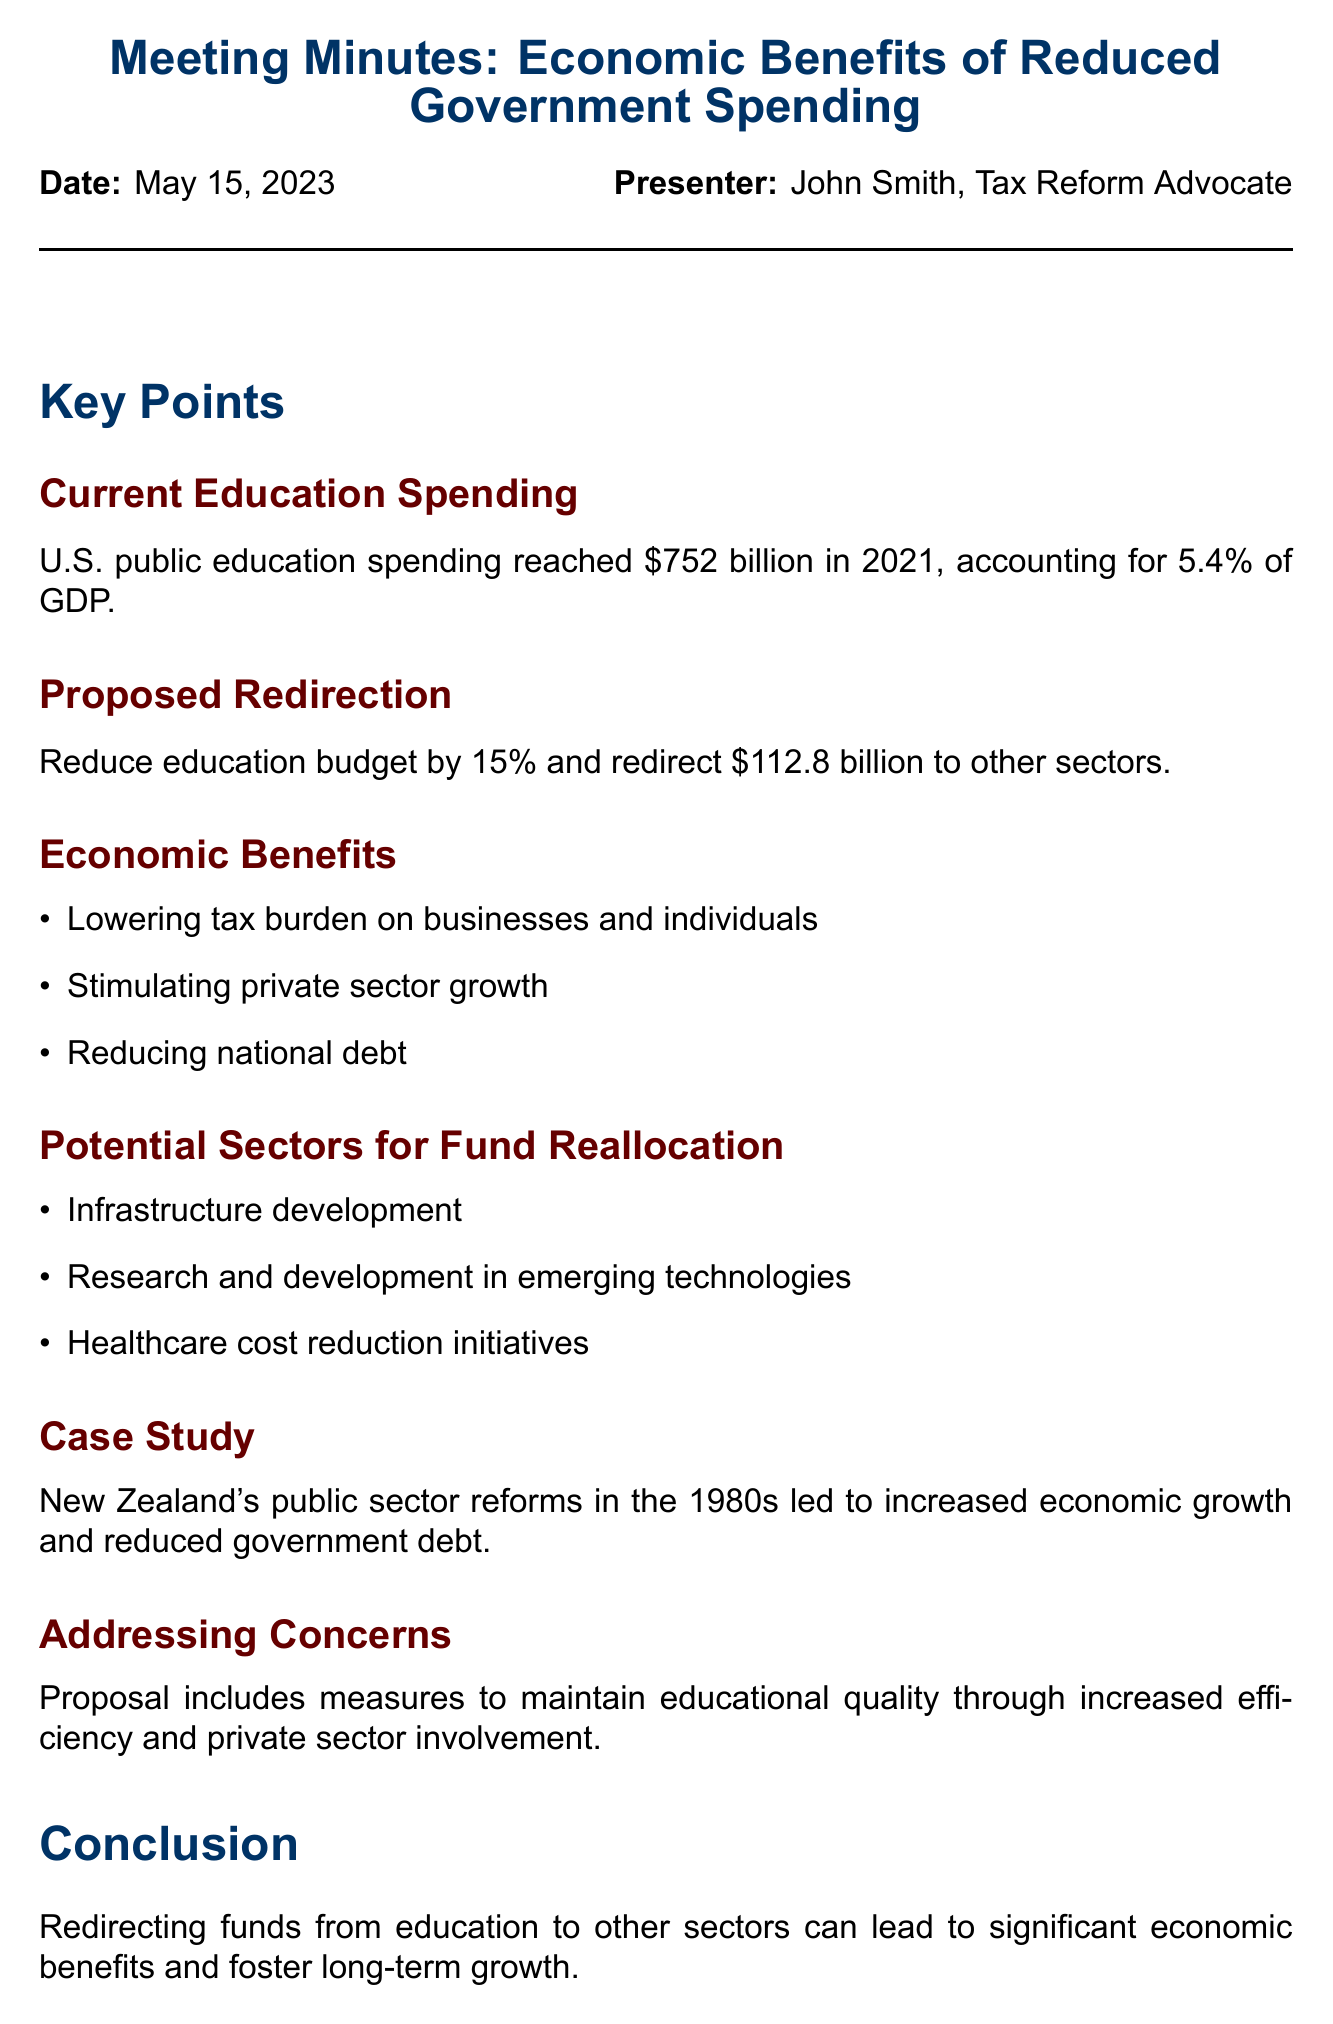What is the date of the meeting? The date of the meeting is stated at the beginning of the document.
Answer: May 15, 2023 Who is the presenter of the meeting? The presenter's name is mentioned right after the date.
Answer: John Smith, Tax Reform Advocate What percentage of GDP did U.S. public education spending account for in 2021? The percentage is specified in the section about current education spending.
Answer: 5.4% What is the proposed percentage reduction in the education budget? The proposed reduction is outlined in the proposed redirection section.
Answer: 15% How much money is proposed to be redirected to other sectors? The amount to be redirected is stated in the details of the proposed redirection.
Answer: $112.8 billion What was a significant effect of New Zealand's public sector reforms in the 1980s? The effect is listed in the case study section.
Answer: Increased economic growth What are two potential sectors mentioned for fund reallocation? The sectors are listed under potential sectors for fund reallocation.
Answer: Infrastructure development, Research and development in emerging technologies What is one of the economic benefits listed? The economic benefits are provided as a bullet list.
Answer: Lowering tax burden on businesses and individuals What is one of the next steps proposed after the meeting? The next steps are outlined at the end of the document.
Answer: Conduct detailed analysis of potential economic impact 